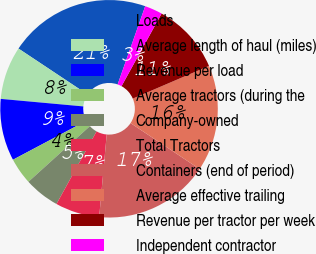<chart> <loc_0><loc_0><loc_500><loc_500><pie_chart><fcel>Loads<fcel>Average length of haul (miles)<fcel>Revenue per load<fcel>Average tractors (during the<fcel>Company-owned<fcel>Total Tractors<fcel>Containers (end of period)<fcel>Average effective trailing<fcel>Revenue per tractor per week<fcel>Independent contractor<nl><fcel>21.05%<fcel>7.89%<fcel>9.21%<fcel>3.95%<fcel>5.26%<fcel>6.58%<fcel>17.1%<fcel>15.79%<fcel>10.53%<fcel>2.63%<nl></chart> 